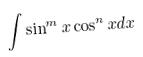Convert formula to latex. <formula><loc_0><loc_0><loc_500><loc_500>\int \sin ^ { m } x \cos ^ { n } x d x</formula> 